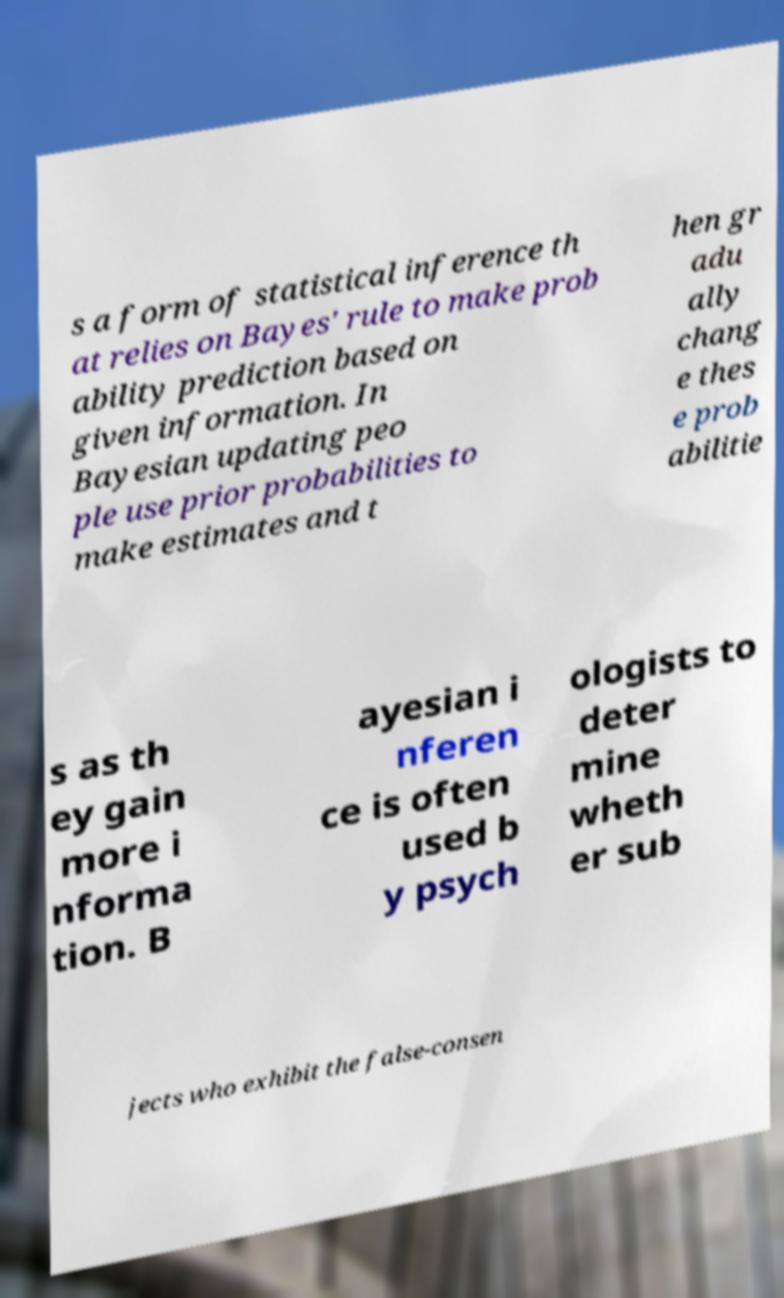There's text embedded in this image that I need extracted. Can you transcribe it verbatim? s a form of statistical inference th at relies on Bayes' rule to make prob ability prediction based on given information. In Bayesian updating peo ple use prior probabilities to make estimates and t hen gr adu ally chang e thes e prob abilitie s as th ey gain more i nforma tion. B ayesian i nferen ce is often used b y psych ologists to deter mine wheth er sub jects who exhibit the false-consen 